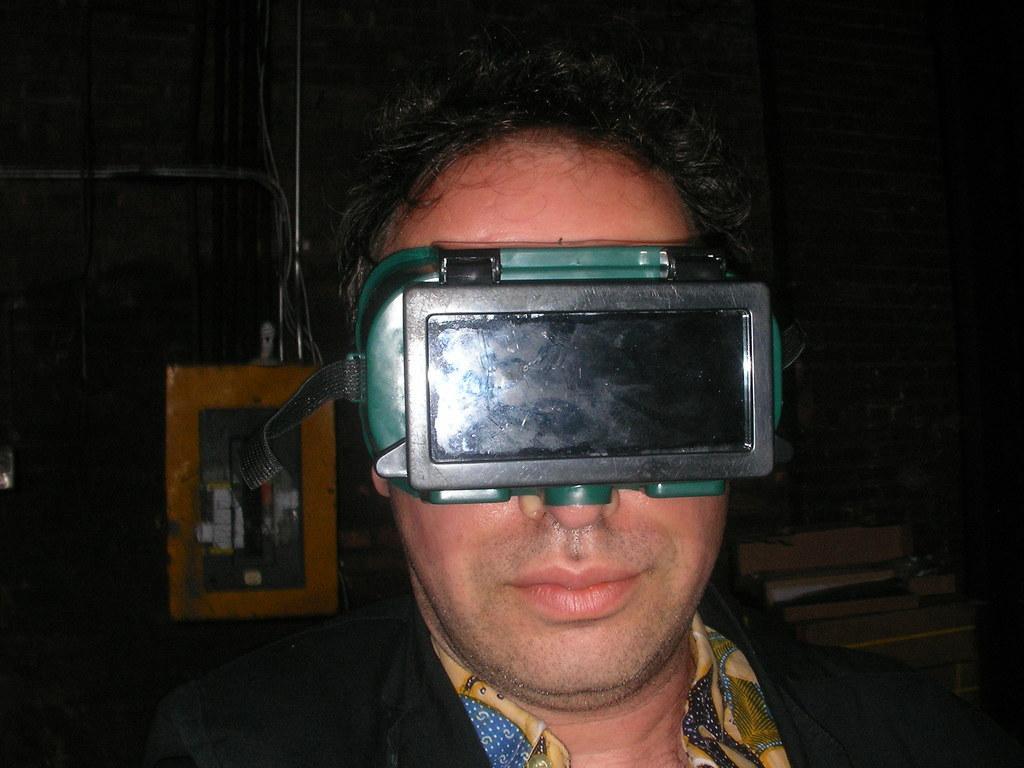Describe this image in one or two sentences. In this picture we can see a person wore a blazer, virtual reality and in the background we can see some objects and it is dark. 